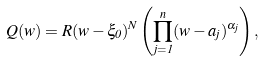Convert formula to latex. <formula><loc_0><loc_0><loc_500><loc_500>Q ( w ) = R ( w - \xi _ { 0 } ) ^ { N } \left ( \prod _ { j = 1 } ^ { n } ( w - a _ { j } ) ^ { \alpha _ { j } } \right ) ,</formula> 